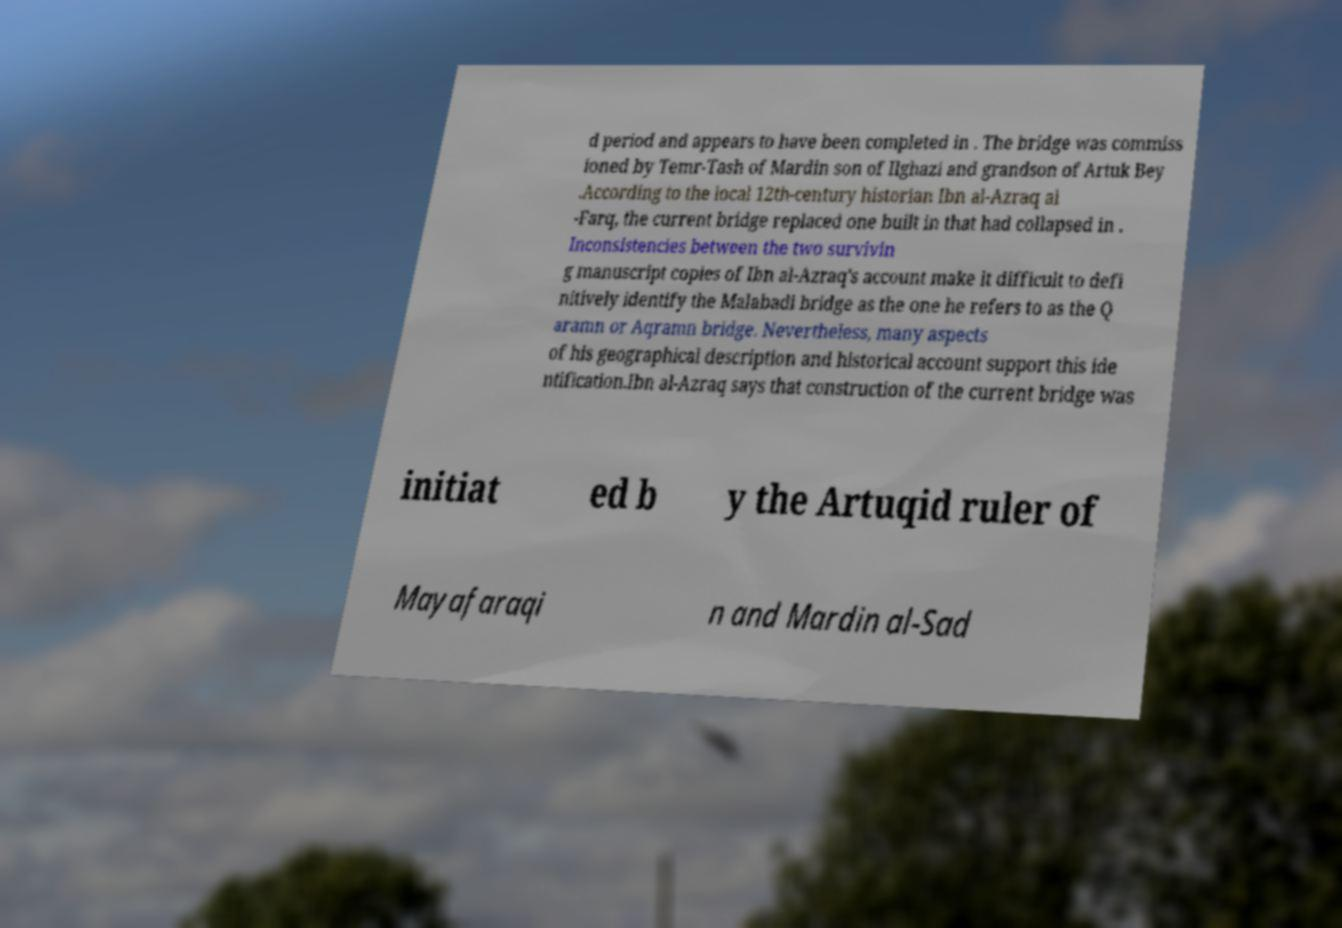What messages or text are displayed in this image? I need them in a readable, typed format. d period and appears to have been completed in . The bridge was commiss ioned by Temr-Tash of Mardin son of Ilghazi and grandson of Artuk Bey .According to the local 12th-century historian Ibn al-Azraq al -Farq, the current bridge replaced one built in that had collapsed in . Inconsistencies between the two survivin g manuscript copies of Ibn al-Azraq's account make it difficult to defi nitively identify the Malabadi bridge as the one he refers to as the Q aramn or Aqramn bridge. Nevertheless, many aspects of his geographical description and historical account support this ide ntification.Ibn al-Azraq says that construction of the current bridge was initiat ed b y the Artuqid ruler of Mayafaraqi n and Mardin al-Sad 